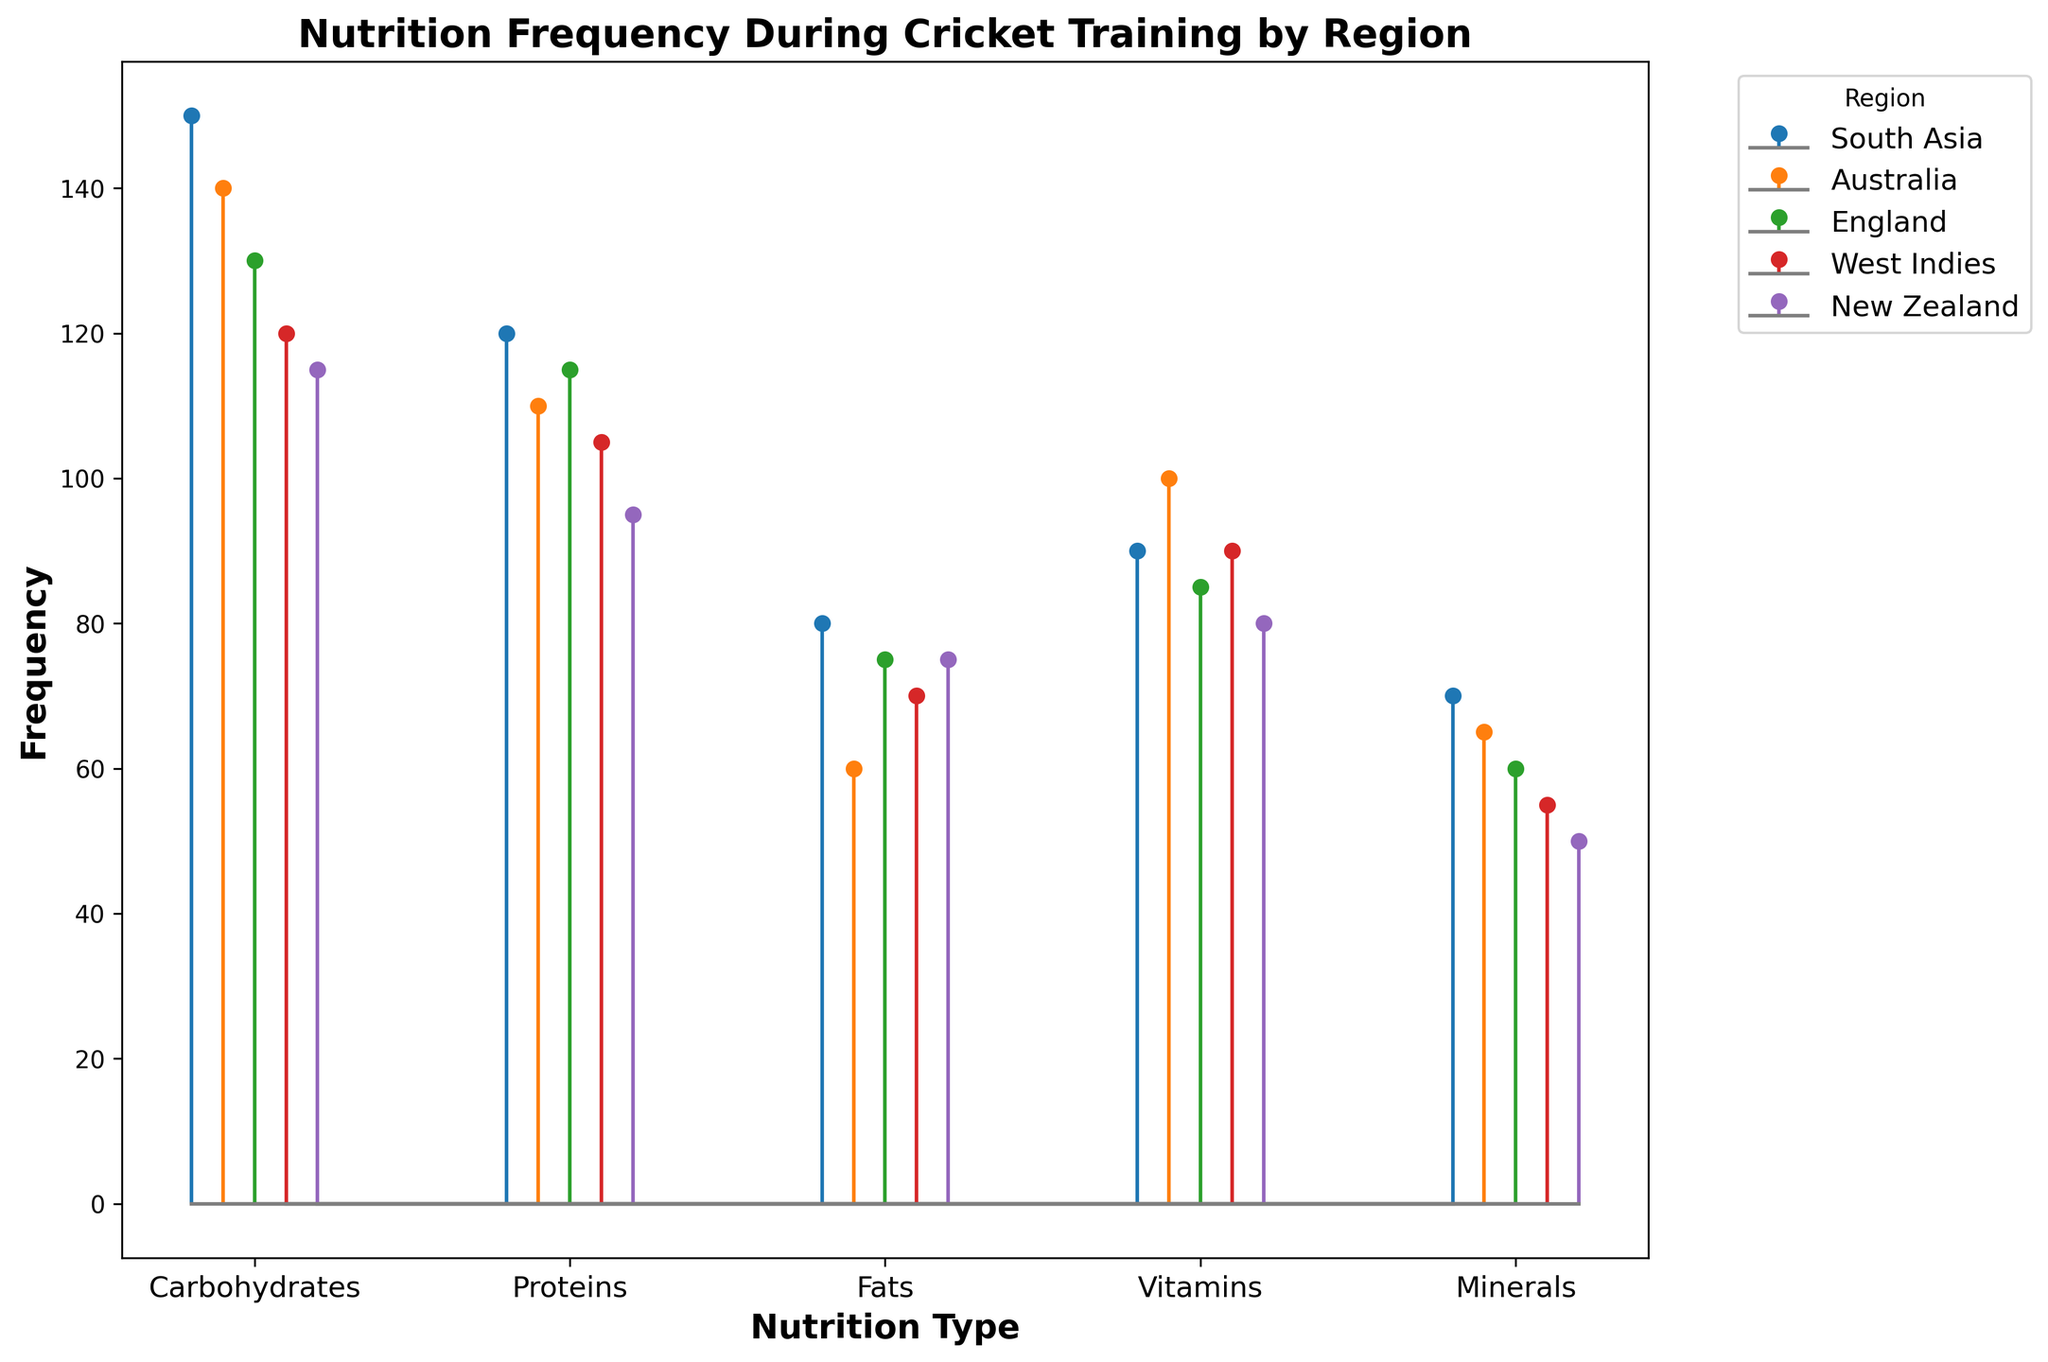Which region consumes the most Carbohydrates? By observing the figure, one can see that each region has a different height for Carbohydrates frequency. The region with the highest Carbohydrates bar is South Asia with a frequency of 150.
Answer: South Asia Which nutrition type has the lowest frequency in New Zealand? By examining the heights of New Zealand’s stems, one can see that the shortest stem is for Minerals, which has a frequency of 50.
Answer: Minerals How much greater is the frequency of Proteins compared to Fats in Australia? Look at the heights of the stems for Proteins and Fats in Australia. Proteins have 110 and Fats have 60. The difference is 110 - 60 = 50.
Answer: 50 What's the total frequency of Vitamins across all regions? Sum the frequencies of Vitamins across all regions: 90 (South Asia) + 100 (Australia) + 85 (England) + 90 (West Indies) + 80 (New Zealand) = 445.
Answer: 445 Which region has the highest frequency of Fats? Examine the heights of the stems for Fats in all regions. South Asia has the highest frequency at 80.
Answer: South Asia What is the average frequency of Minerals across all regions? Sum the frequencies of Minerals: 70 (South Asia) + 65 (Australia) + 60 (England) + 55 (West Indies) + 50 (New Zealand). This equals 300. Then, divide by 5 (number of regions): 300 / 5 = 60.
Answer: 60 Which region has the greatest difference between Carbohydrates and Minerals frequency? Calculate the difference for each region: South Asia (150 - 70 = 80), Australia (140 - 65 = 75), England (130 - 60 = 70), West Indies (120 - 55 = 65), New Zealand (115 - 50 = 65). South Asia has the greatest difference at 80.
Answer: South Asia Which nutrition type has the closest frequencies amongst all regions? Compare the frequencies of each nutrition type across all regions. Minerals and Fats have relatively close frequencies but Minerals show less variance.
Answer: Minerals Which region has the lowest frequency of Carbohydrates? By looking at the heights of the Carbohydrates stems, New Zealand has the lowest frequency at 115.
Answer: New Zealand How many more Proteins are consumed in South Asia than in West Indies? South Asia consumes 120 Proteins, while West Indies consumes 105. The difference is 120 - 105 = 15.
Answer: 15 